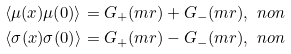<formula> <loc_0><loc_0><loc_500><loc_500>& \langle \mu ( x ) \mu ( 0 ) \rangle = G _ { + } ( m r ) + G _ { - } ( m r ) , \ n o n \\ & \langle \sigma ( x ) \sigma ( 0 ) \rangle = G _ { + } ( m r ) - G _ { - } ( m r ) , \ n o n</formula> 